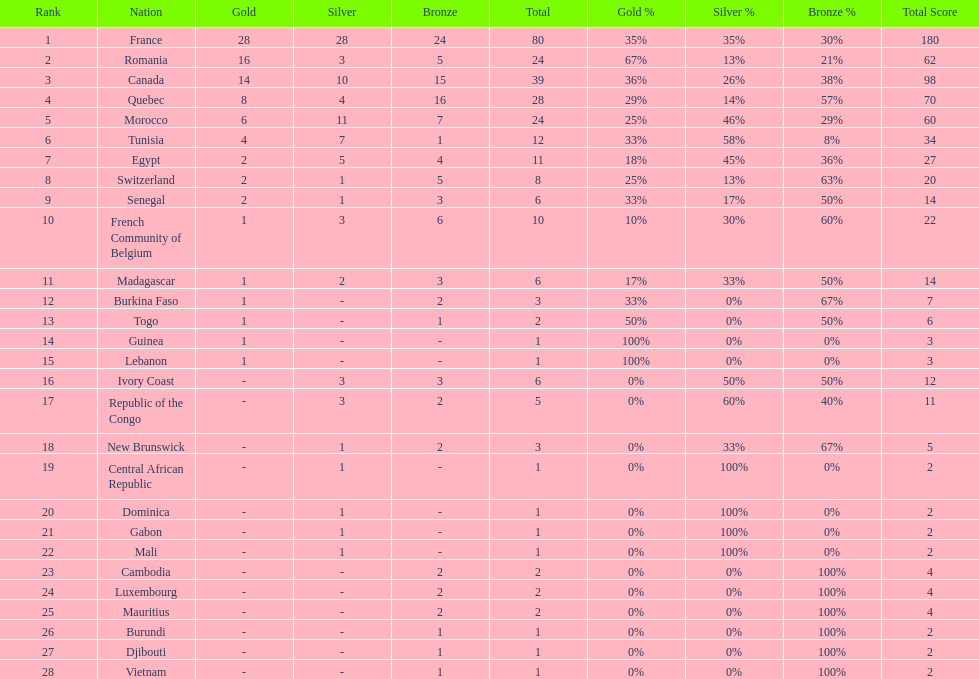How many bronze medals does togo have? 1. Would you be able to parse every entry in this table? {'header': ['Rank', 'Nation', 'Gold', 'Silver', 'Bronze', 'Total', 'Gold %', 'Silver %', 'Bronze %', 'Total Score'], 'rows': [['1', 'France', '28', '28', '24', '80', '35%', '35%', '30%', '180'], ['2', 'Romania', '16', '3', '5', '24', '67%', '13%', '21%', '62'], ['3', 'Canada', '14', '10', '15', '39', '36%', '26%', '38%', '98'], ['4', 'Quebec', '8', '4', '16', '28', '29%', '14%', '57%', '70'], ['5', 'Morocco', '6', '11', '7', '24', '25%', '46%', '29%', '60'], ['6', 'Tunisia', '4', '7', '1', '12', '33%', '58%', '8%', '34'], ['7', 'Egypt', '2', '5', '4', '11', '18%', '45%', '36%', '27'], ['8', 'Switzerland', '2', '1', '5', '8', '25%', '13%', '63%', '20'], ['9', 'Senegal', '2', '1', '3', '6', '33%', '17%', '50%', '14'], ['10', 'French Community of Belgium', '1', '3', '6', '10', '10%', '30%', '60%', '22'], ['11', 'Madagascar', '1', '2', '3', '6', '17%', '33%', '50%', '14'], ['12', 'Burkina Faso', '1', '-', '2', '3', '33%', '0%', '67%', '7'], ['13', 'Togo', '1', '-', '1', '2', '50%', '0%', '50%', '6'], ['14', 'Guinea', '1', '-', '-', '1', '100%', '0%', '0%', '3'], ['15', 'Lebanon', '1', '-', '-', '1', '100%', '0%', '0%', '3'], ['16', 'Ivory Coast', '-', '3', '3', '6', '0%', '50%', '50%', '12'], ['17', 'Republic of the Congo', '-', '3', '2', '5', '0%', '60%', '40%', '11'], ['18', 'New Brunswick', '-', '1', '2', '3', '0%', '33%', '67%', '5'], ['19', 'Central African Republic', '-', '1', '-', '1', '0%', '100%', '0%', '2'], ['20', 'Dominica', '-', '1', '-', '1', '0%', '100%', '0%', '2'], ['21', 'Gabon', '-', '1', '-', '1', '0%', '100%', '0%', '2'], ['22', 'Mali', '-', '1', '-', '1', '0%', '100%', '0%', '2'], ['23', 'Cambodia', '-', '-', '2', '2', '0%', '0%', '100%', '4'], ['24', 'Luxembourg', '-', '-', '2', '2', '0%', '0%', '100%', '4'], ['25', 'Mauritius', '-', '-', '2', '2', '0%', '0%', '100%', '4'], ['26', 'Burundi', '-', '-', '1', '1', '0%', '0%', '100%', '2'], ['27', 'Djibouti', '-', '-', '1', '1', '0%', '0%', '100%', '2'], ['28', 'Vietnam', '-', '-', '1', '1', '0%', '0%', '100%', '2']]} 